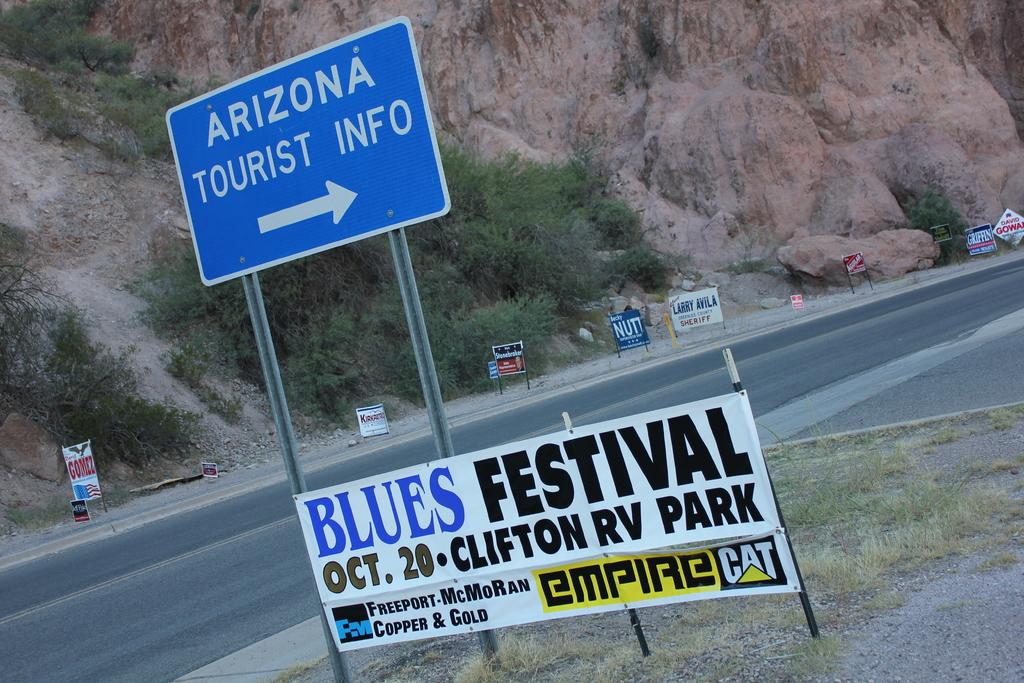<image>
Describe the image concisely. A street sign directing people to Arizona Tourist Information 